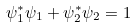<formula> <loc_0><loc_0><loc_500><loc_500>\psi _ { 1 } ^ { * } \psi _ { 1 } + \psi _ { 2 } ^ { * } \psi _ { 2 } = 1</formula> 